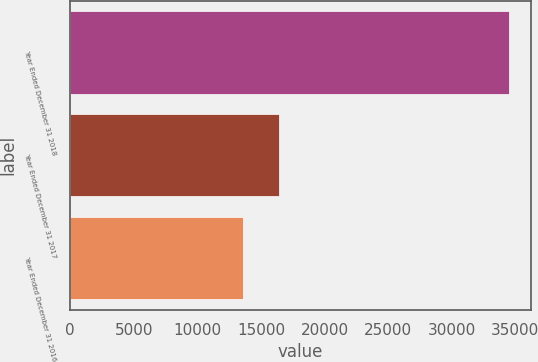<chart> <loc_0><loc_0><loc_500><loc_500><bar_chart><fcel>Year Ended December 31 2018<fcel>Year Ended December 31 2017<fcel>Year Ended December 31 2016<nl><fcel>34479<fcel>16381<fcel>13619<nl></chart> 